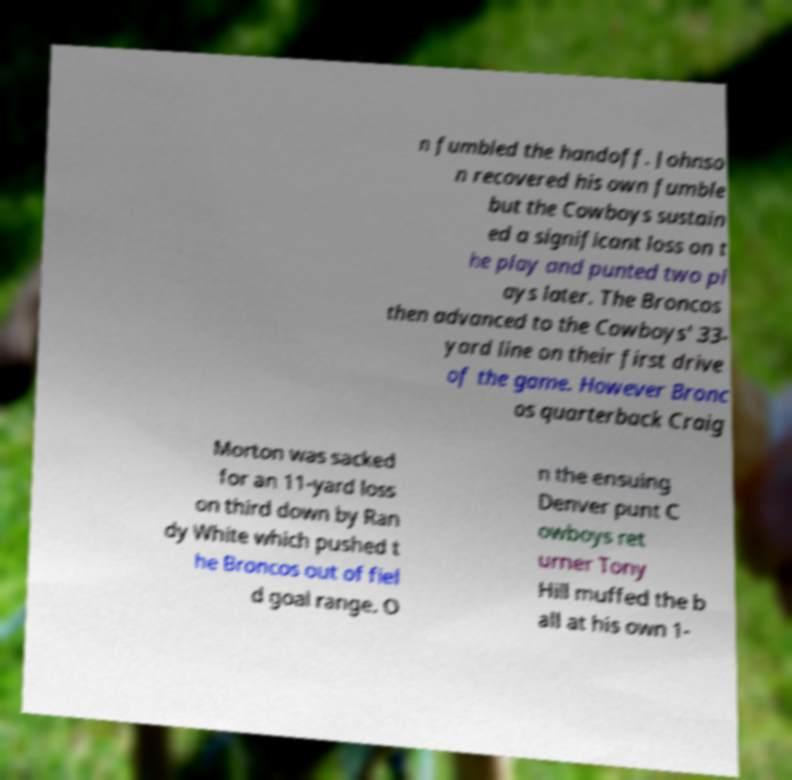Can you accurately transcribe the text from the provided image for me? n fumbled the handoff. Johnso n recovered his own fumble but the Cowboys sustain ed a significant loss on t he play and punted two pl ays later. The Broncos then advanced to the Cowboys' 33- yard line on their first drive of the game. However Bronc os quarterback Craig Morton was sacked for an 11-yard loss on third down by Ran dy White which pushed t he Broncos out of fiel d goal range. O n the ensuing Denver punt C owboys ret urner Tony Hill muffed the b all at his own 1- 